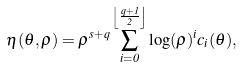<formula> <loc_0><loc_0><loc_500><loc_500>\eta ( \theta , \rho ) = \rho ^ { s + q } \sum _ { i = 0 } ^ { \left \lfloor \frac { q + 1 } { 2 } \right \rfloor } \log ( \rho ) ^ { i } c _ { i } ( \theta ) ,</formula> 